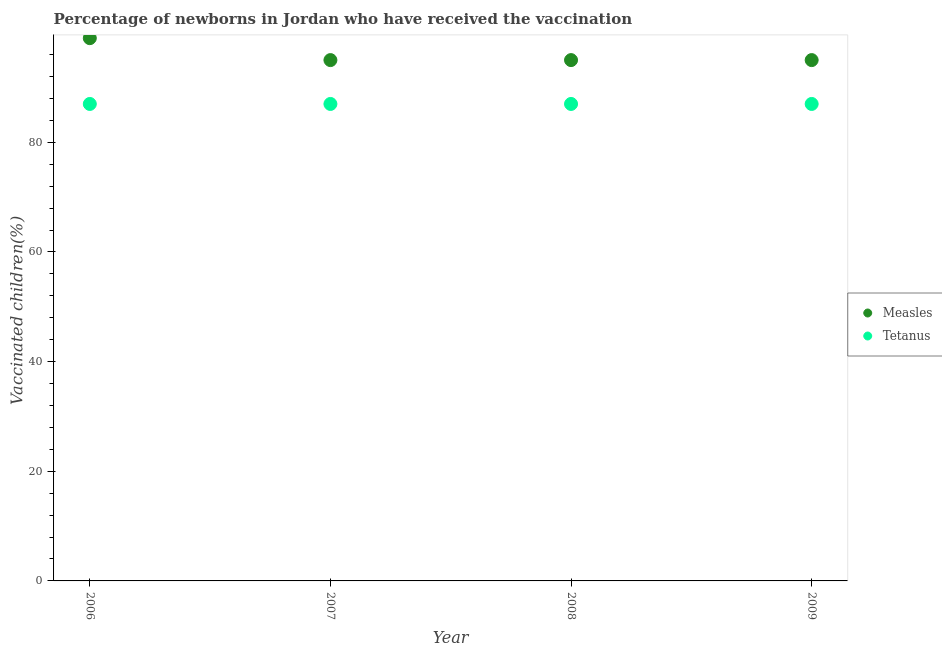What is the percentage of newborns who received vaccination for tetanus in 2007?
Your response must be concise. 87. Across all years, what is the maximum percentage of newborns who received vaccination for measles?
Your answer should be very brief. 99. Across all years, what is the minimum percentage of newborns who received vaccination for measles?
Give a very brief answer. 95. In which year was the percentage of newborns who received vaccination for tetanus minimum?
Offer a very short reply. 2006. What is the total percentage of newborns who received vaccination for measles in the graph?
Keep it short and to the point. 384. What is the difference between the percentage of newborns who received vaccination for tetanus in 2009 and the percentage of newborns who received vaccination for measles in 2008?
Give a very brief answer. -8. What is the average percentage of newborns who received vaccination for measles per year?
Ensure brevity in your answer.  96. In the year 2008, what is the difference between the percentage of newborns who received vaccination for tetanus and percentage of newborns who received vaccination for measles?
Your response must be concise. -8. What is the ratio of the percentage of newborns who received vaccination for measles in 2006 to that in 2007?
Your response must be concise. 1.04. Is the difference between the percentage of newborns who received vaccination for measles in 2006 and 2009 greater than the difference between the percentage of newborns who received vaccination for tetanus in 2006 and 2009?
Give a very brief answer. Yes. What is the difference between the highest and the second highest percentage of newborns who received vaccination for tetanus?
Keep it short and to the point. 0. What is the difference between the highest and the lowest percentage of newborns who received vaccination for measles?
Provide a short and direct response. 4. Does the percentage of newborns who received vaccination for measles monotonically increase over the years?
Offer a terse response. No. Is the percentage of newborns who received vaccination for measles strictly greater than the percentage of newborns who received vaccination for tetanus over the years?
Give a very brief answer. Yes. How many years are there in the graph?
Provide a succinct answer. 4. What is the difference between two consecutive major ticks on the Y-axis?
Ensure brevity in your answer.  20. Are the values on the major ticks of Y-axis written in scientific E-notation?
Offer a terse response. No. How are the legend labels stacked?
Offer a very short reply. Vertical. What is the title of the graph?
Your answer should be compact. Percentage of newborns in Jordan who have received the vaccination. Does "Lowest 10% of population" appear as one of the legend labels in the graph?
Provide a short and direct response. No. What is the label or title of the Y-axis?
Make the answer very short. Vaccinated children(%)
. What is the Vaccinated children(%)
 in Measles in 2006?
Make the answer very short. 99. What is the Vaccinated children(%)
 of Tetanus in 2006?
Your answer should be very brief. 87. What is the Vaccinated children(%)
 in Measles in 2007?
Make the answer very short. 95. What is the Vaccinated children(%)
 in Tetanus in 2007?
Your answer should be very brief. 87. What is the Vaccinated children(%)
 in Tetanus in 2008?
Provide a succinct answer. 87. What is the Vaccinated children(%)
 in Tetanus in 2009?
Your response must be concise. 87. Across all years, what is the maximum Vaccinated children(%)
 in Tetanus?
Provide a succinct answer. 87. What is the total Vaccinated children(%)
 of Measles in the graph?
Your answer should be compact. 384. What is the total Vaccinated children(%)
 in Tetanus in the graph?
Your response must be concise. 348. What is the difference between the Vaccinated children(%)
 in Measles in 2006 and that in 2007?
Your answer should be compact. 4. What is the difference between the Vaccinated children(%)
 in Measles in 2006 and that in 2008?
Ensure brevity in your answer.  4. What is the difference between the Vaccinated children(%)
 in Tetanus in 2006 and that in 2008?
Ensure brevity in your answer.  0. What is the difference between the Vaccinated children(%)
 in Measles in 2006 and that in 2009?
Your response must be concise. 4. What is the difference between the Vaccinated children(%)
 of Tetanus in 2006 and that in 2009?
Your answer should be compact. 0. What is the difference between the Vaccinated children(%)
 in Tetanus in 2008 and that in 2009?
Give a very brief answer. 0. What is the difference between the Vaccinated children(%)
 of Measles in 2006 and the Vaccinated children(%)
 of Tetanus in 2007?
Give a very brief answer. 12. What is the difference between the Vaccinated children(%)
 of Measles in 2006 and the Vaccinated children(%)
 of Tetanus in 2008?
Your response must be concise. 12. What is the difference between the Vaccinated children(%)
 in Measles in 2006 and the Vaccinated children(%)
 in Tetanus in 2009?
Give a very brief answer. 12. What is the difference between the Vaccinated children(%)
 of Measles in 2008 and the Vaccinated children(%)
 of Tetanus in 2009?
Your response must be concise. 8. What is the average Vaccinated children(%)
 in Measles per year?
Your answer should be compact. 96. What is the average Vaccinated children(%)
 of Tetanus per year?
Make the answer very short. 87. In the year 2008, what is the difference between the Vaccinated children(%)
 of Measles and Vaccinated children(%)
 of Tetanus?
Offer a very short reply. 8. What is the ratio of the Vaccinated children(%)
 of Measles in 2006 to that in 2007?
Your answer should be compact. 1.04. What is the ratio of the Vaccinated children(%)
 of Tetanus in 2006 to that in 2007?
Make the answer very short. 1. What is the ratio of the Vaccinated children(%)
 in Measles in 2006 to that in 2008?
Your answer should be compact. 1.04. What is the ratio of the Vaccinated children(%)
 in Measles in 2006 to that in 2009?
Your response must be concise. 1.04. What is the ratio of the Vaccinated children(%)
 in Tetanus in 2006 to that in 2009?
Your answer should be very brief. 1. What is the ratio of the Vaccinated children(%)
 in Measles in 2007 to that in 2008?
Give a very brief answer. 1. What is the ratio of the Vaccinated children(%)
 in Tetanus in 2007 to that in 2008?
Your response must be concise. 1. What is the ratio of the Vaccinated children(%)
 of Measles in 2008 to that in 2009?
Your answer should be compact. 1. What is the difference between the highest and the second highest Vaccinated children(%)
 in Measles?
Keep it short and to the point. 4. What is the difference between the highest and the lowest Vaccinated children(%)
 in Tetanus?
Offer a terse response. 0. 